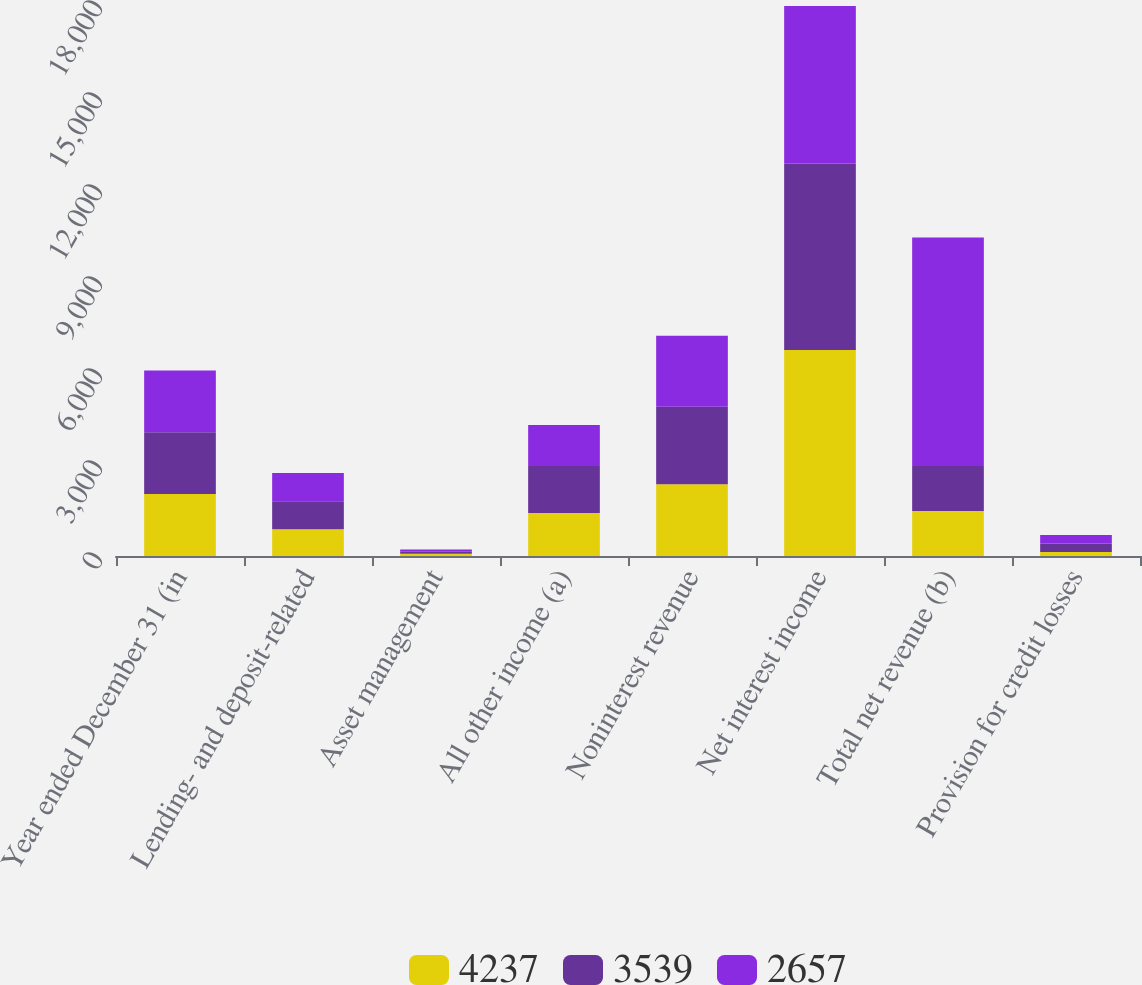<chart> <loc_0><loc_0><loc_500><loc_500><stacked_bar_chart><ecel><fcel>Year ended December 31 (in<fcel>Lending- and deposit-related<fcel>Asset management<fcel>All other income (a)<fcel>Noninterest revenue<fcel>Net interest income<fcel>Total net revenue (b)<fcel>Provision for credit losses<nl><fcel>4237<fcel>2018<fcel>870<fcel>73<fcel>1400<fcel>2343<fcel>6716<fcel>1467.5<fcel>129<nl><fcel>3539<fcel>2017<fcel>919<fcel>68<fcel>1535<fcel>2522<fcel>6083<fcel>1467.5<fcel>276<nl><fcel>2657<fcel>2016<fcel>917<fcel>69<fcel>1334<fcel>2320<fcel>5133<fcel>7453<fcel>282<nl></chart> 